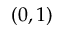<formula> <loc_0><loc_0><loc_500><loc_500>( 0 , 1 )</formula> 